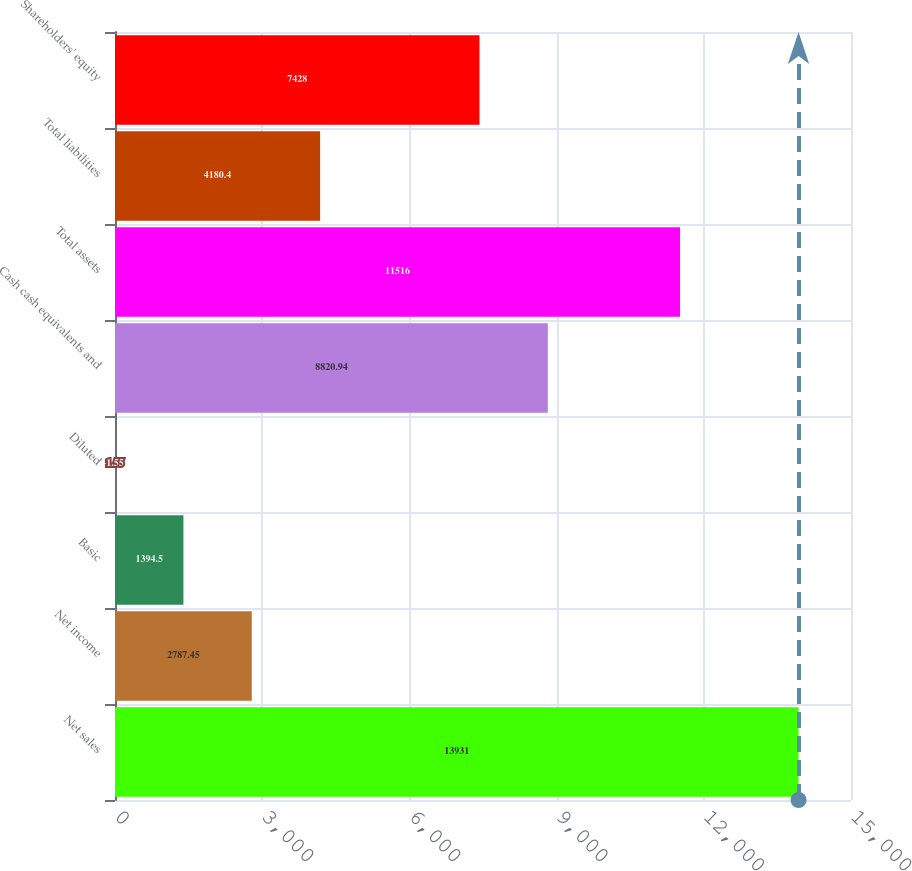Convert chart to OTSL. <chart><loc_0><loc_0><loc_500><loc_500><bar_chart><fcel>Net sales<fcel>Net income<fcel>Basic<fcel>Diluted<fcel>Cash cash equivalents and<fcel>Total assets<fcel>Total liabilities<fcel>Shareholders' equity<nl><fcel>13931<fcel>2787.45<fcel>1394.5<fcel>1.55<fcel>8820.94<fcel>11516<fcel>4180.4<fcel>7428<nl></chart> 